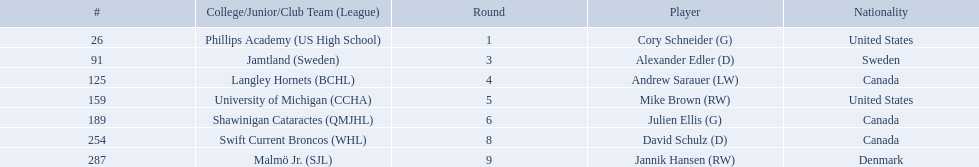Which players have canadian nationality? Andrew Sarauer (LW), Julien Ellis (G), David Schulz (D). Of those, which attended langley hornets? Andrew Sarauer (LW). 